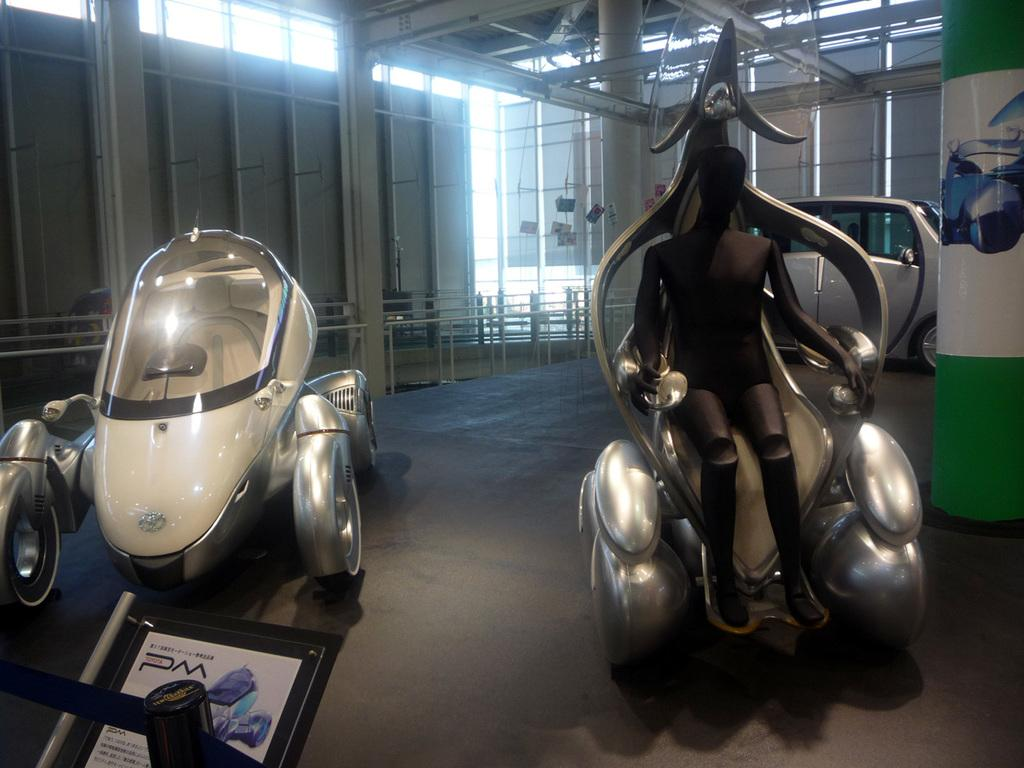What type of objects can be seen in the image? There are vehicles in the image. Where are the vehicles located? The vehicles are in a room. What else can be seen in the room besides the vehicles? There are lights visible in the image. Is there any signage or identification in the room? Yes, there is a name board in the image. How many beds are visible in the image? There are no beds present in the image. Is there a vase with flowers on the road in the image? There is no road or vase with flowers in the image; it features vehicles in a room. 